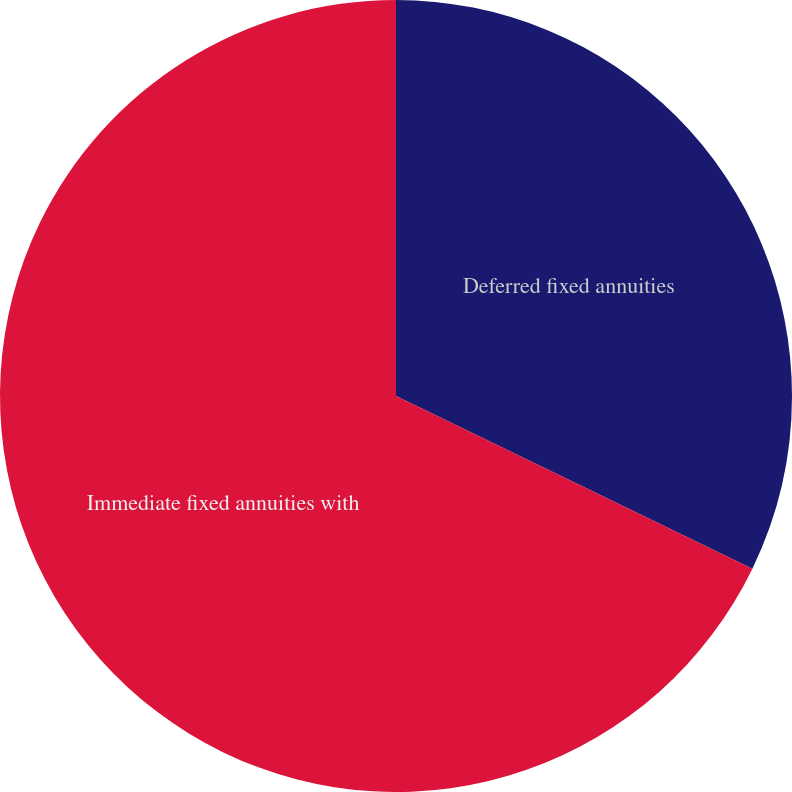Convert chart to OTSL. <chart><loc_0><loc_0><loc_500><loc_500><pie_chart><fcel>Deferred fixed annuities<fcel>Immediate fixed annuities with<nl><fcel>32.18%<fcel>67.82%<nl></chart> 